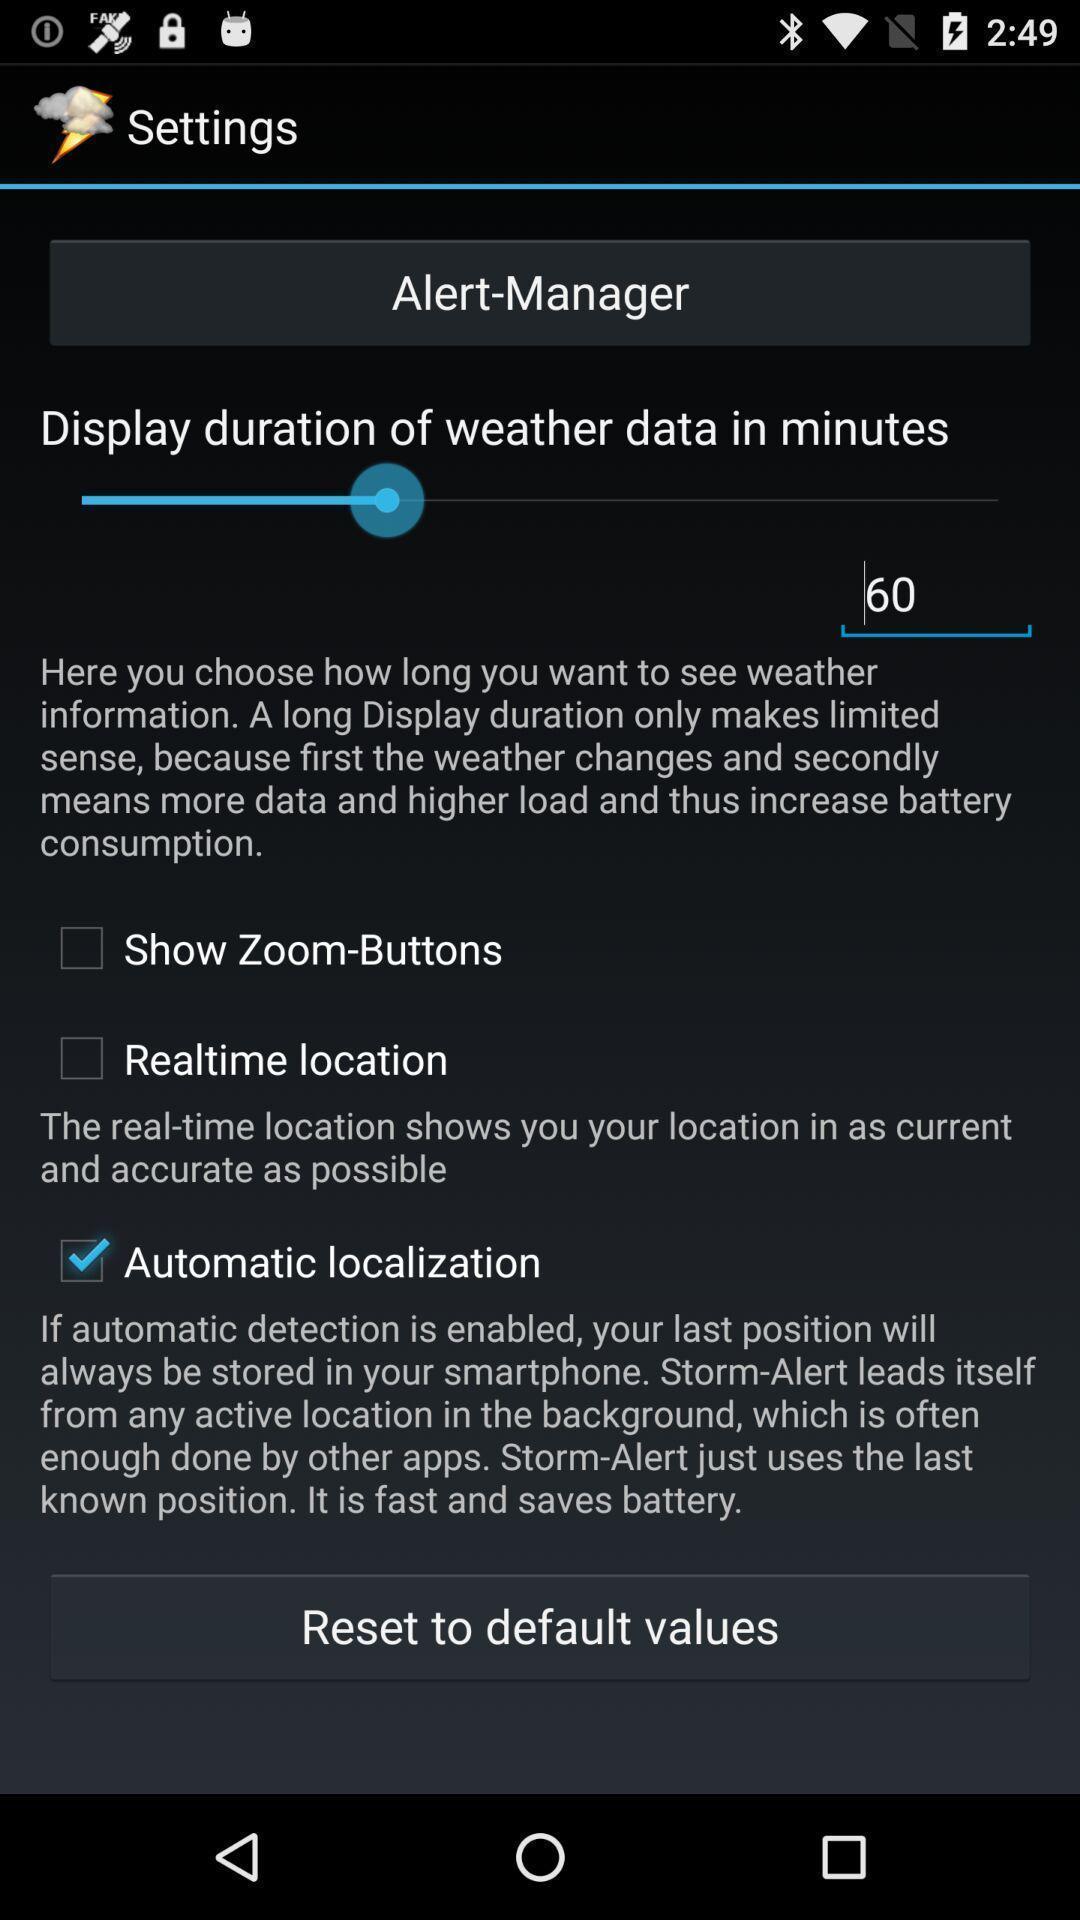Tell me what you see in this picture. Settings page. 